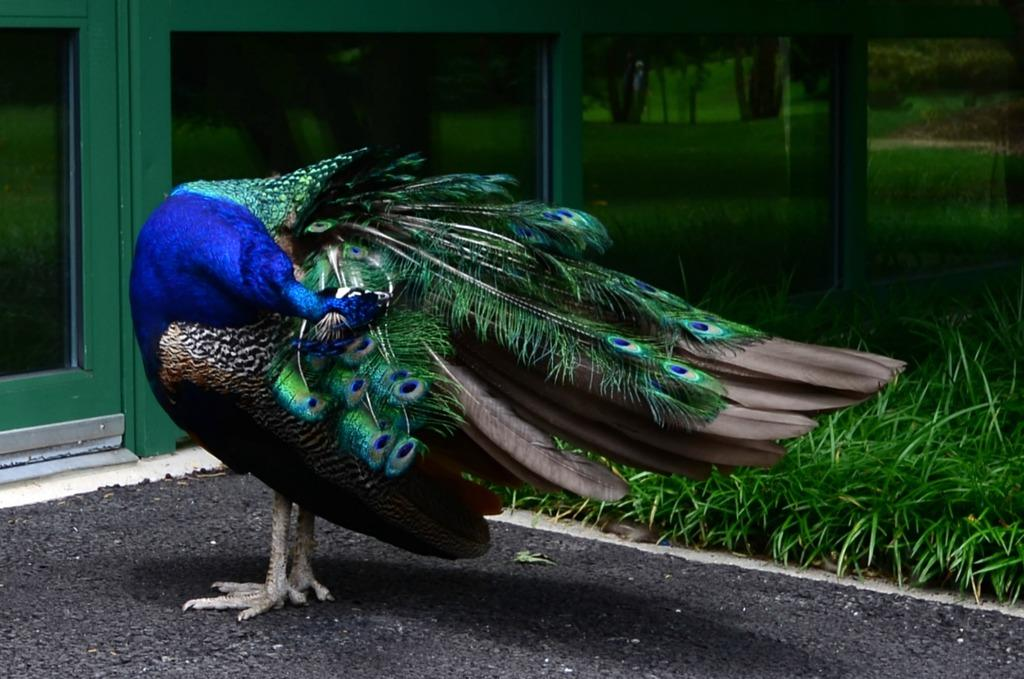What type of animal is in the image? There is a peacock in the image. Where is the peacock located? The peacock is on the land. What type of vegetation can be seen in the image? There is grass visible in the image. What architectural feature can be seen in the background of the image? There are glass doors in the background of the image. What type of stew is being prepared in the image? There is no stew present in the image; it features a peacock on the land with grass and glass doors in the background. How many wings does the peacock have in the image? The peacock has two wings in the image, but the question is unnecessary as the focus should be on the facts provided. 